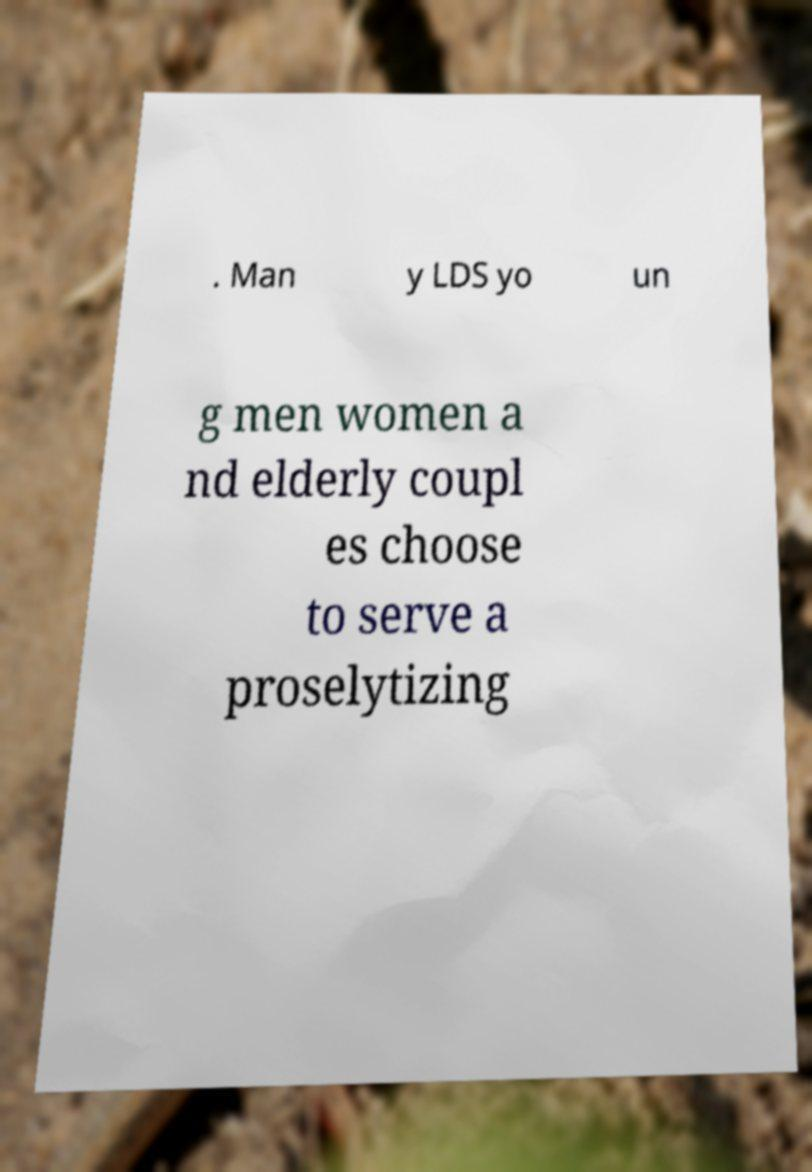What messages or text are displayed in this image? I need them in a readable, typed format. . Man y LDS yo un g men women a nd elderly coupl es choose to serve a proselytizing 